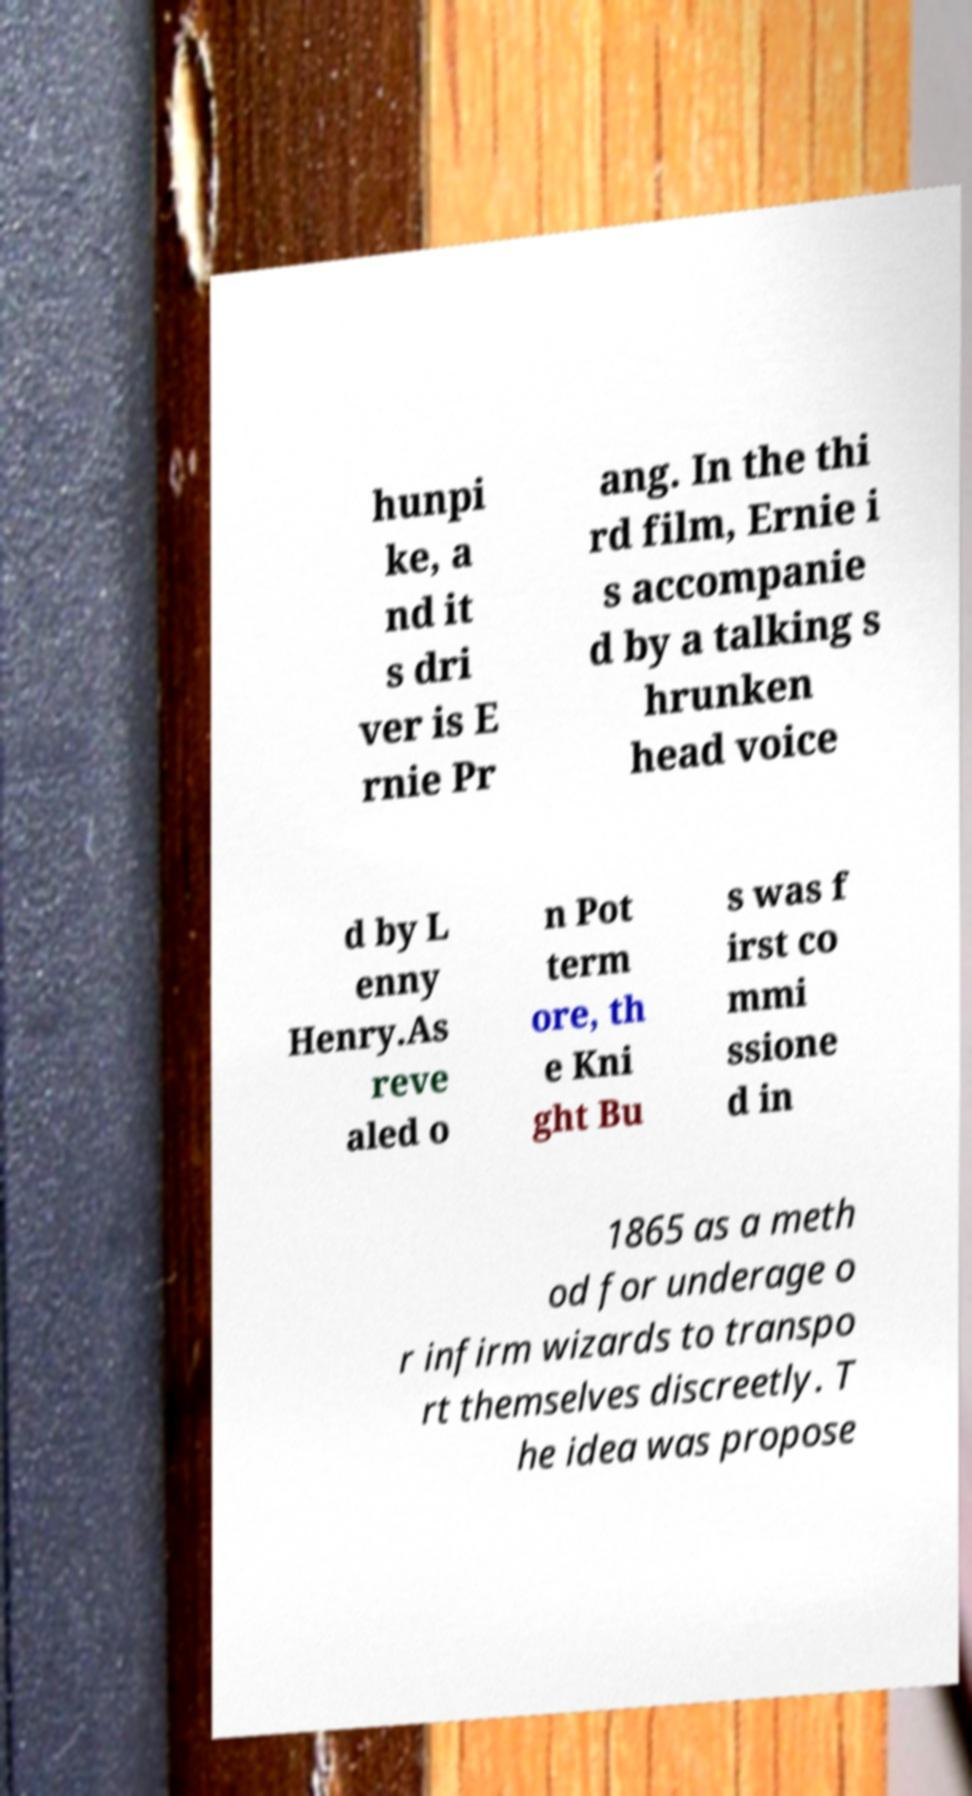Please read and relay the text visible in this image. What does it say? hunpi ke, a nd it s dri ver is E rnie Pr ang. In the thi rd film, Ernie i s accompanie d by a talking s hrunken head voice d by L enny Henry.As reve aled o n Pot term ore, th e Kni ght Bu s was f irst co mmi ssione d in 1865 as a meth od for underage o r infirm wizards to transpo rt themselves discreetly. T he idea was propose 